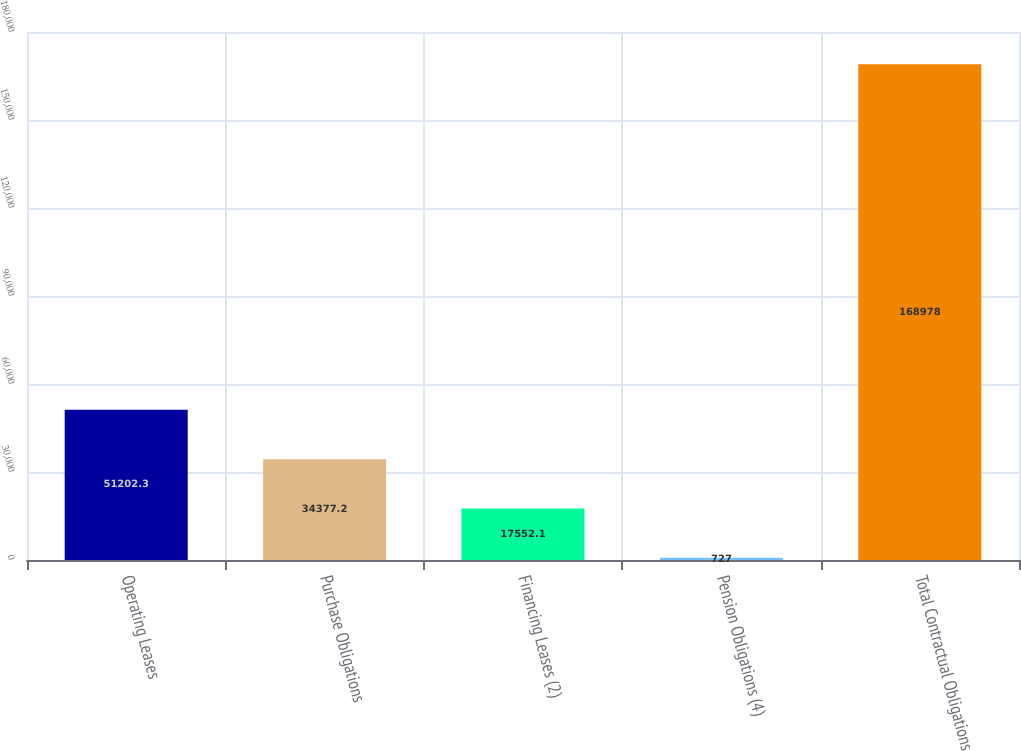<chart> <loc_0><loc_0><loc_500><loc_500><bar_chart><fcel>Operating Leases<fcel>Purchase Obligations<fcel>Financing Leases (2)<fcel>Pension Obligations (4)<fcel>Total Contractual Obligations<nl><fcel>51202.3<fcel>34377.2<fcel>17552.1<fcel>727<fcel>168978<nl></chart> 